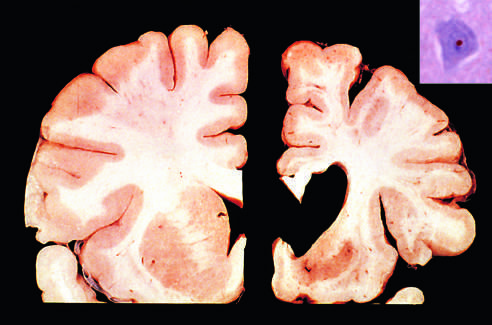what is strongly immunoreactive for ubiquitin?
Answer the question using a single word or phrase. An intranuclear inclusion in a cortical neuron 